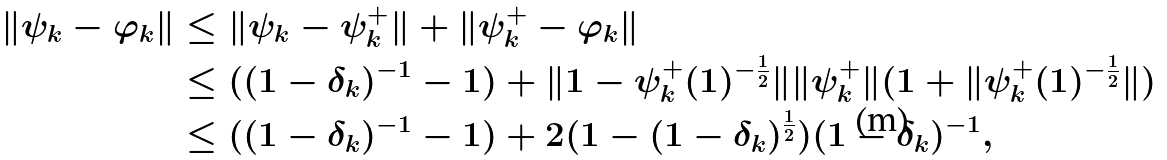<formula> <loc_0><loc_0><loc_500><loc_500>\| \psi _ { k } - \varphi _ { k } \| & \leq \| \psi _ { k } - \psi ^ { + } _ { k } \| + \| \psi ^ { + } _ { k } - \varphi _ { k } \| \\ & \leq ( ( 1 - \delta _ { k } ) ^ { - 1 } - 1 ) + \| 1 - \psi ^ { + } _ { k } ( 1 ) ^ { - \frac { 1 } { 2 } } \| \| \psi ^ { + } _ { k } \| ( 1 + \| \psi ^ { + } _ { k } ( 1 ) ^ { - \frac { 1 } { 2 } } \| ) \\ & \leq ( ( 1 - \delta _ { k } ) ^ { - 1 } - 1 ) + 2 ( 1 - ( 1 - \delta _ { k } ) ^ { \frac { 1 } { 2 } } ) ( 1 - \delta _ { k } ) ^ { - 1 } ,</formula> 